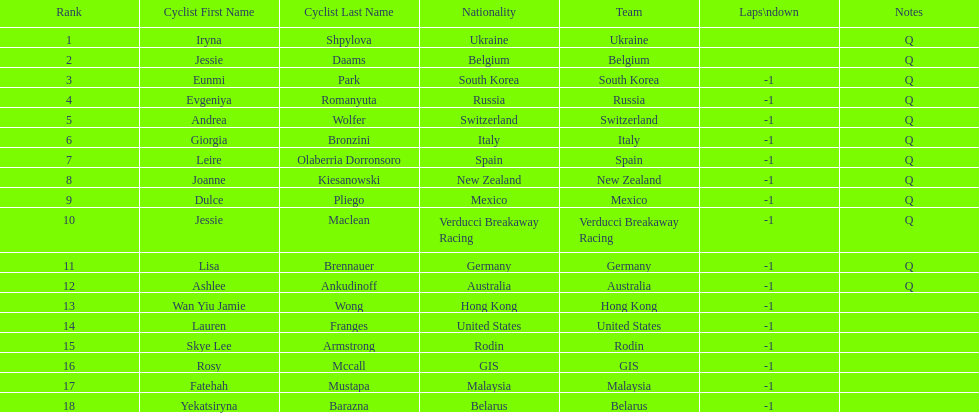Who is the last cyclist listed? Yekatsiryna Barazna. 